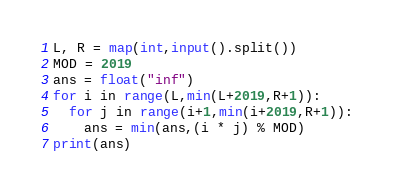Convert code to text. <code><loc_0><loc_0><loc_500><loc_500><_Python_>L, R = map(int,input().split())
MOD = 2019
ans = float("inf")
for i in range(L,min(L+2019,R+1)):
  for j in range(i+1,min(i+2019,R+1)):
    ans = min(ans,(i * j) % MOD)
print(ans)</code> 